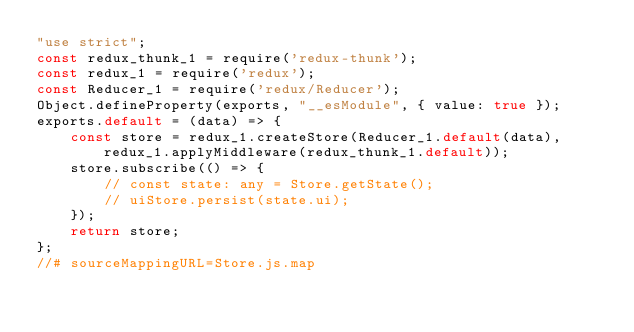<code> <loc_0><loc_0><loc_500><loc_500><_JavaScript_>"use strict";
const redux_thunk_1 = require('redux-thunk');
const redux_1 = require('redux');
const Reducer_1 = require('redux/Reducer');
Object.defineProperty(exports, "__esModule", { value: true });
exports.default = (data) => {
    const store = redux_1.createStore(Reducer_1.default(data), redux_1.applyMiddleware(redux_thunk_1.default));
    store.subscribe(() => {
        // const state: any = Store.getState();
        // uiStore.persist(state.ui);
    });
    return store;
};
//# sourceMappingURL=Store.js.map</code> 